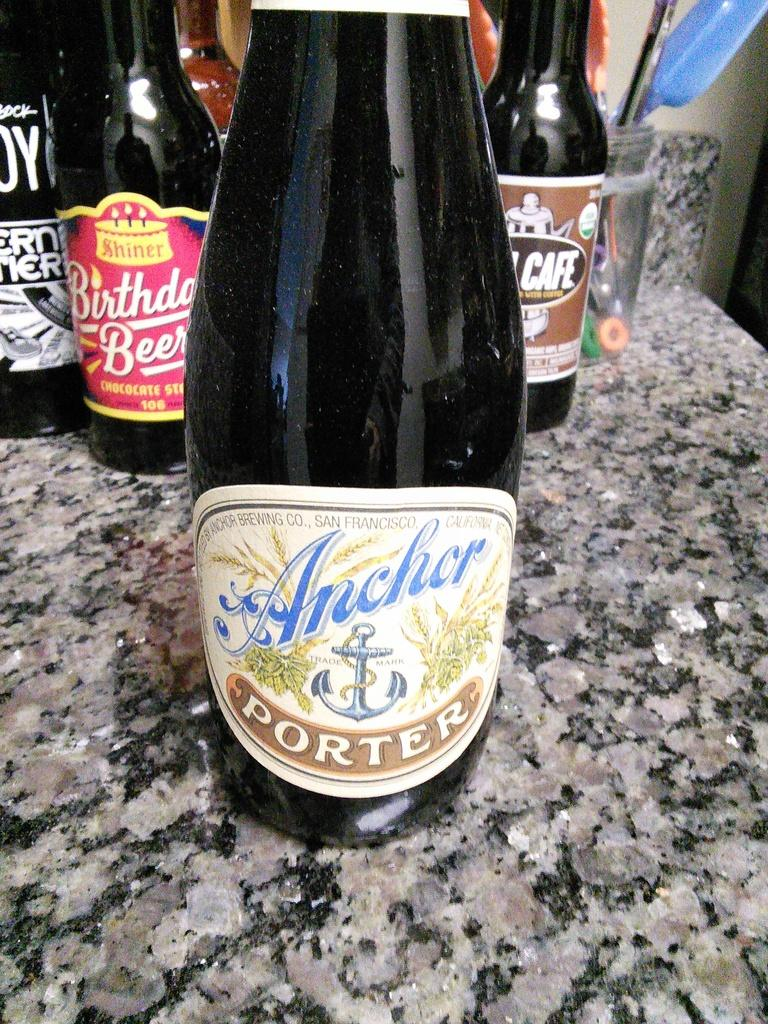<image>
Share a concise interpretation of the image provided. A collection of various bottles on eof which is called Anchor Porter. 